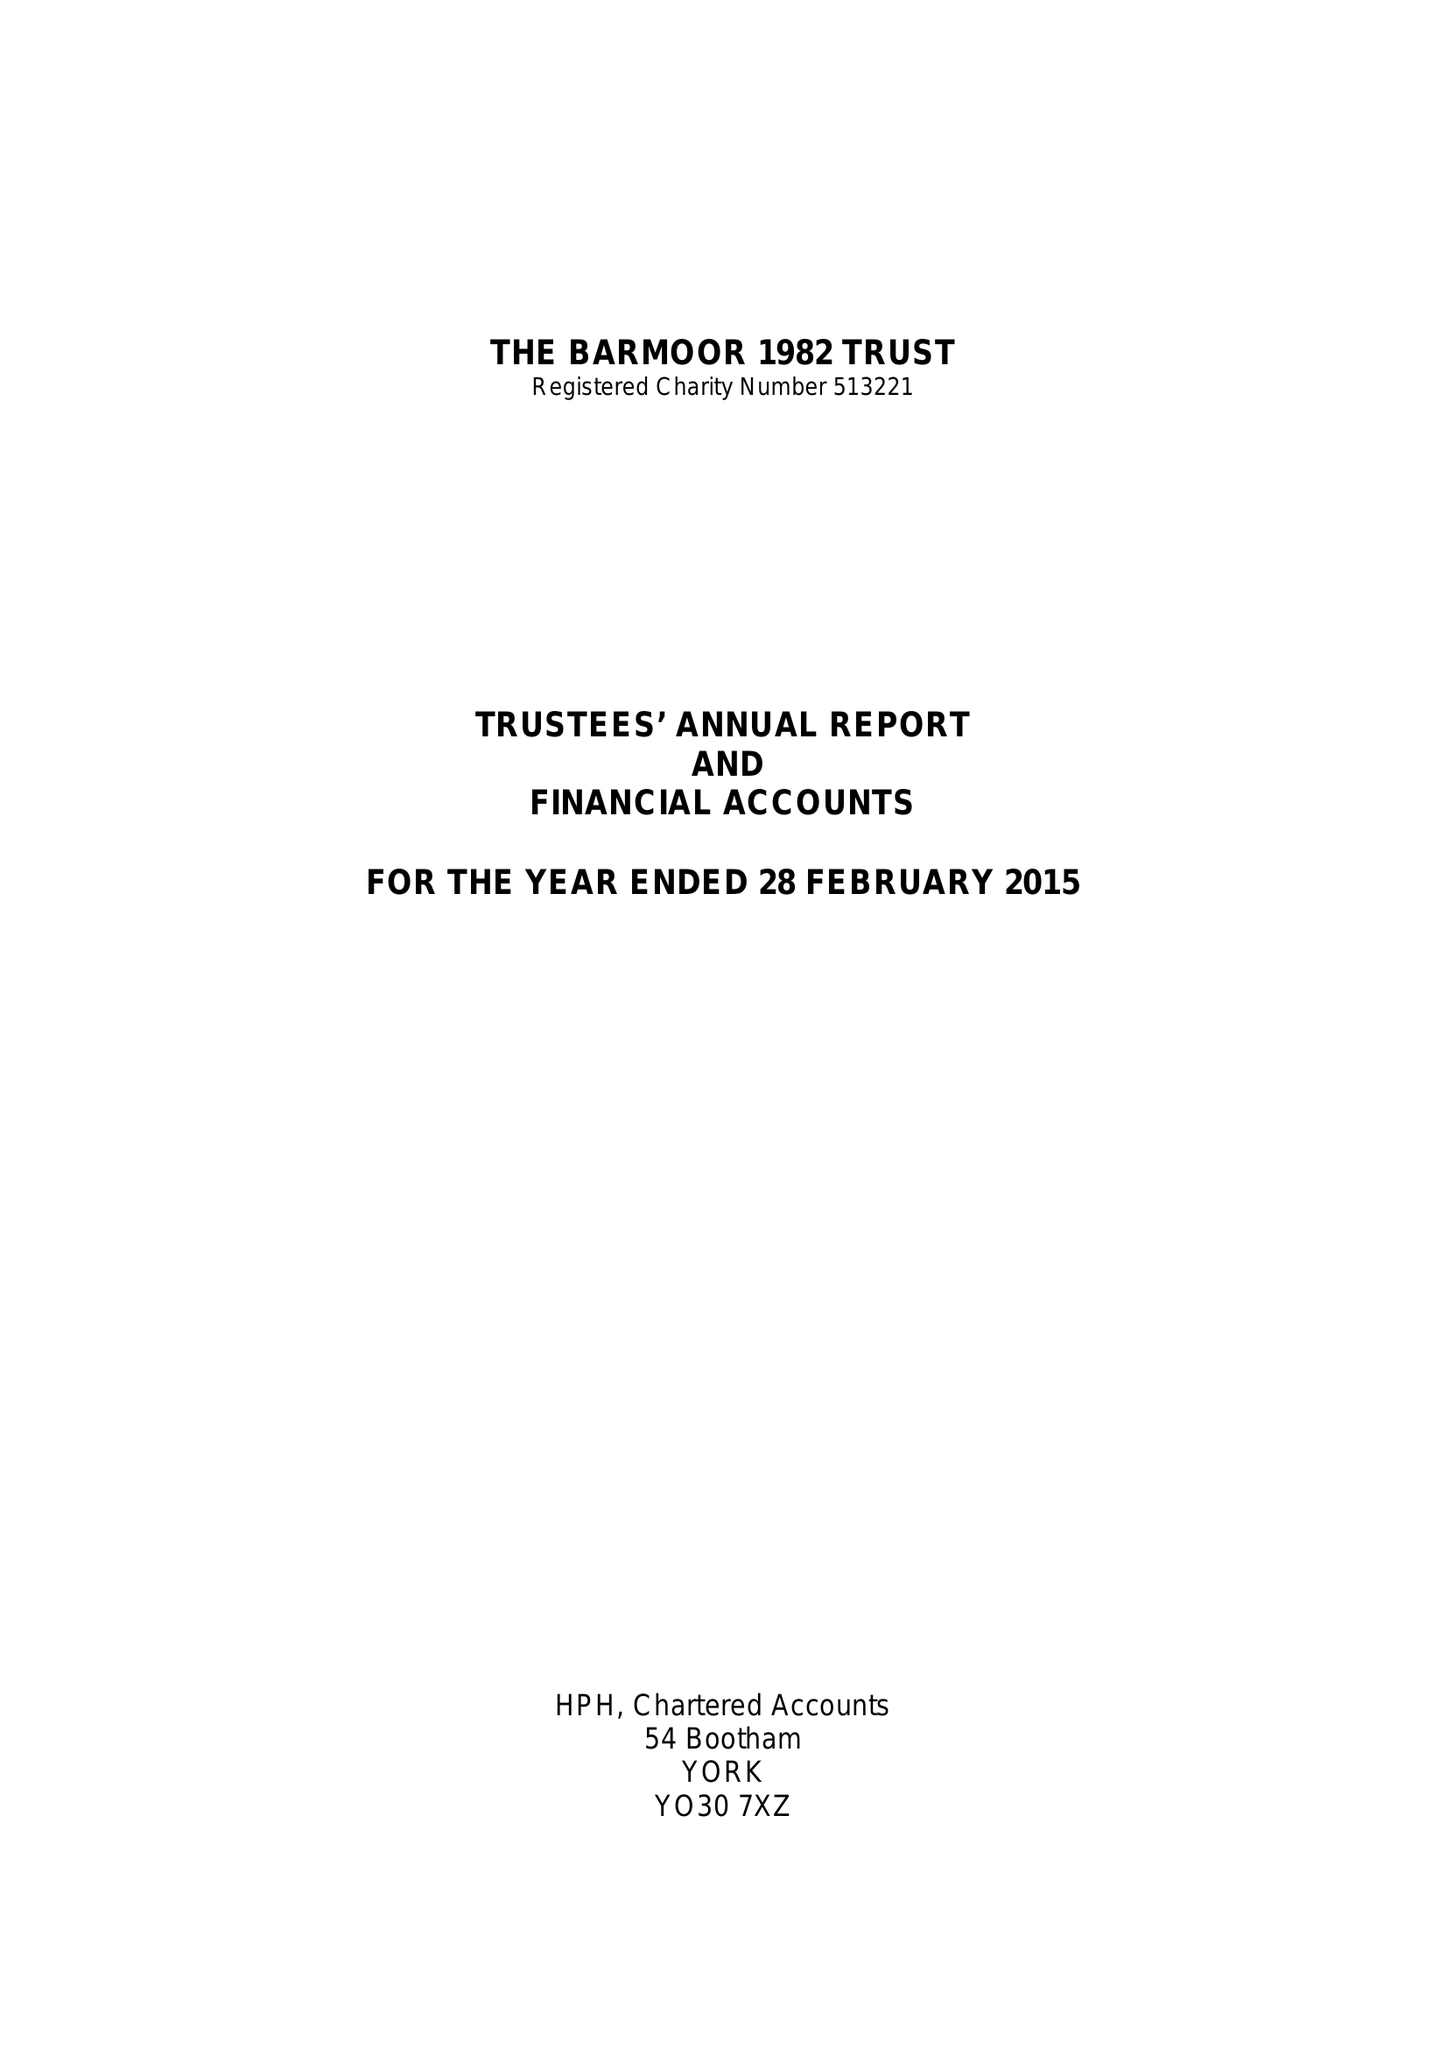What is the value for the income_annually_in_british_pounds?
Answer the question using a single word or phrase. 66192.00 